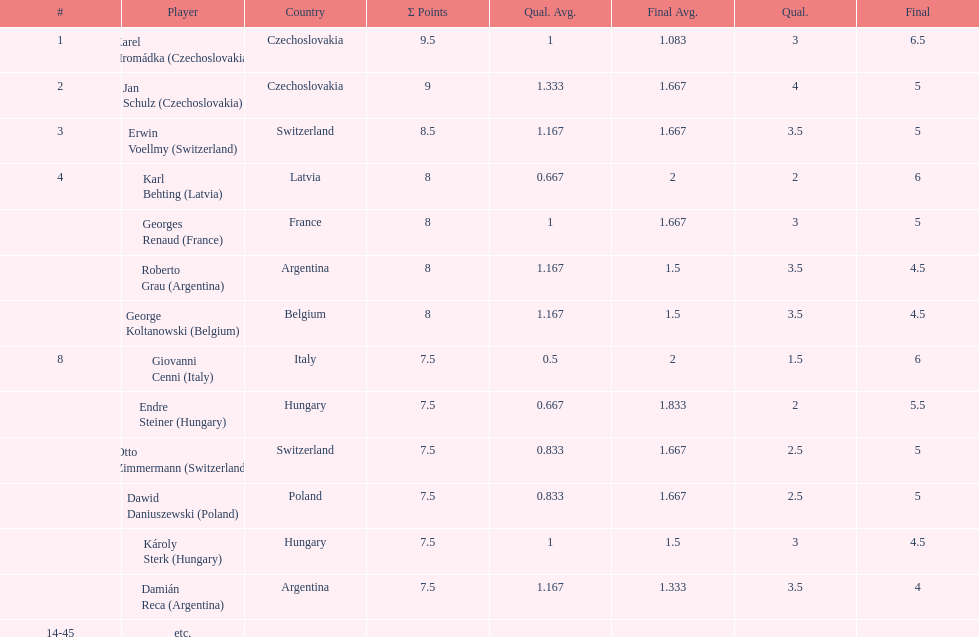How many players had a 8 points? 4. 